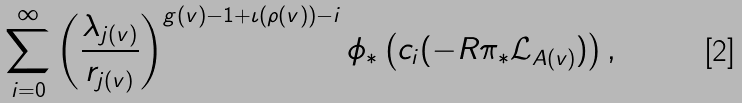<formula> <loc_0><loc_0><loc_500><loc_500>\sum _ { i = 0 } ^ { \infty } \left ( \frac { \lambda _ { j ( v ) } } { r _ { j ( v ) } } \right ) ^ { g ( v ) - 1 + \iota ( \rho ( v ) ) - i } \phi _ { * } \left ( c _ { i } ( - R \pi _ { * } \mathcal { L } _ { A ( v ) } ) \right ) ,</formula> 